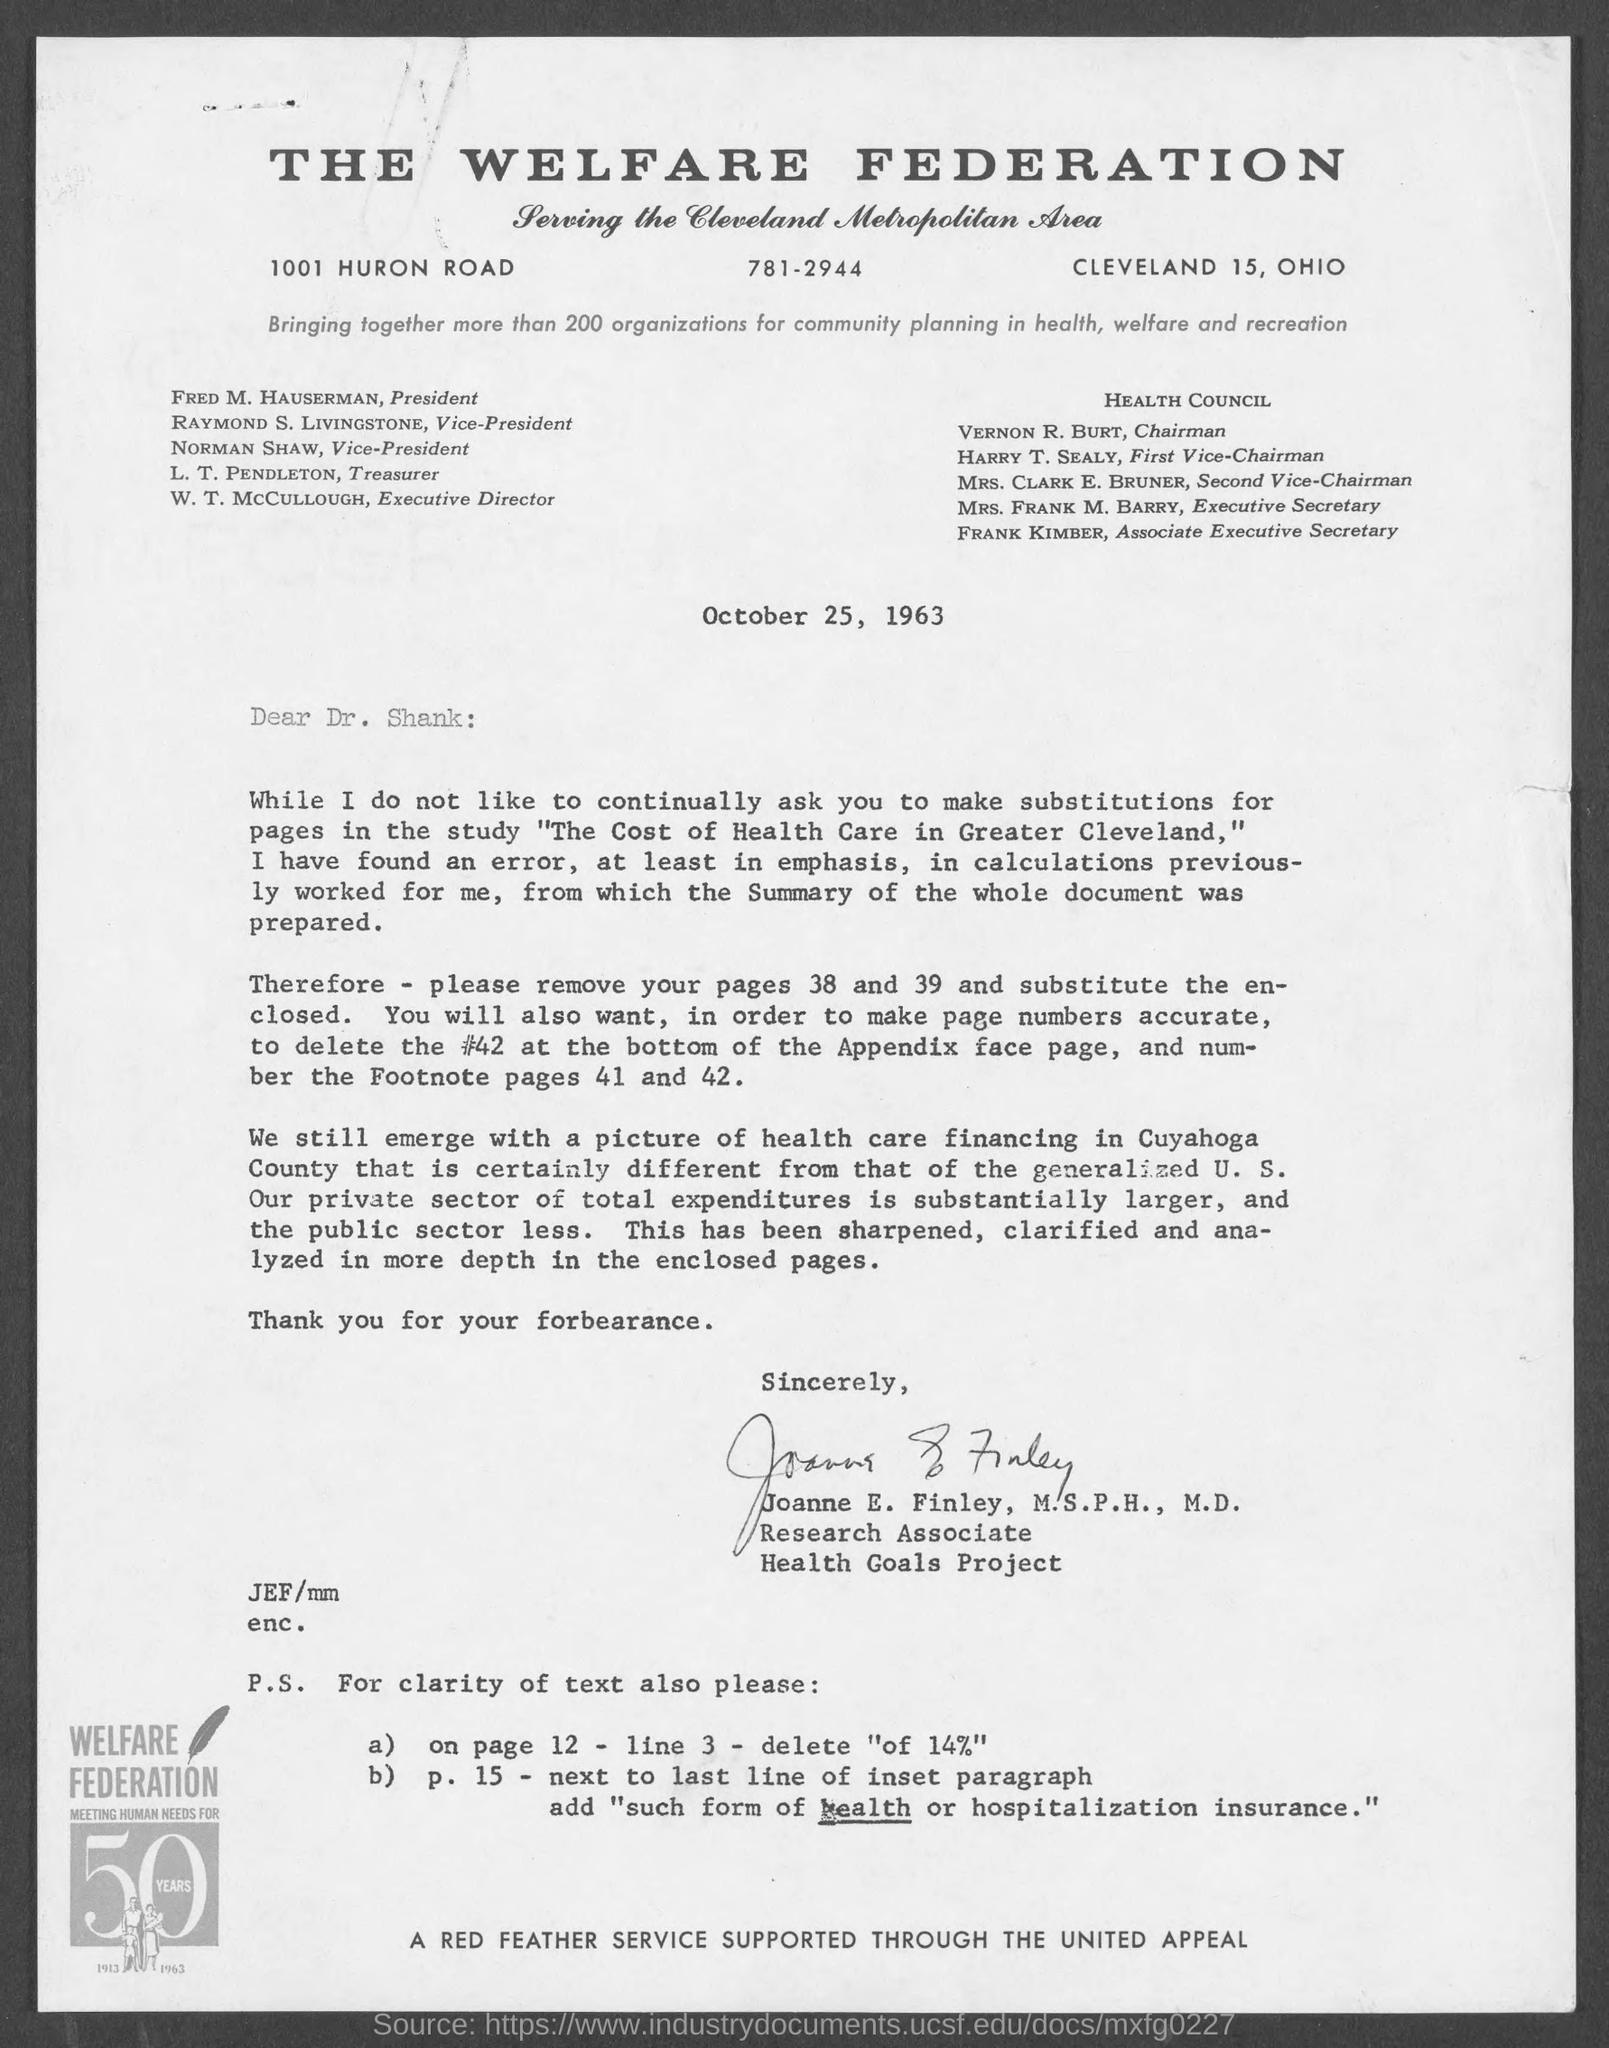Mention a couple of crucial points in this snapshot. The date on the document is October 25, 1963. The letter is from Joanne E. Finley, who holds a Master of Science in Public Health (M.S.P.H.) and a Medical Degree (M.D.). The letter is addressed to Dr. Shank. The document is titled the Welfare Federation. 